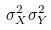Convert formula to latex. <formula><loc_0><loc_0><loc_500><loc_500>\sigma _ { X } ^ { 2 } \sigma _ { Y } ^ { 2 }</formula> 